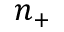<formula> <loc_0><loc_0><loc_500><loc_500>n _ { + }</formula> 